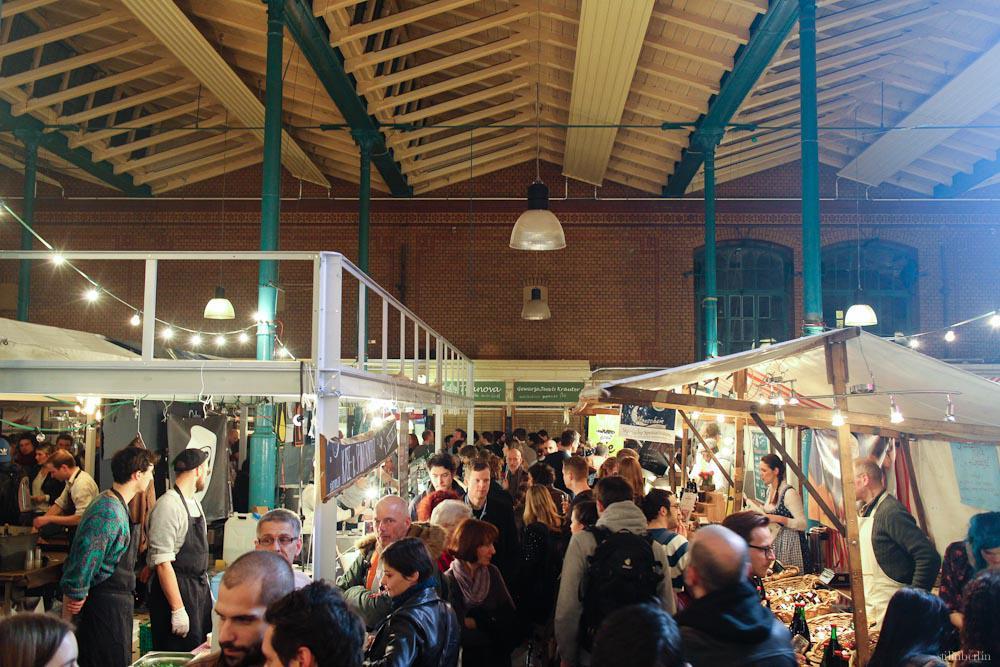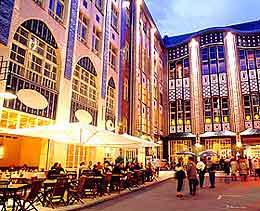The first image is the image on the left, the second image is the image on the right. Given the left and right images, does the statement "In at least one of the images all the chairs are empty." hold true? Answer yes or no. No. 